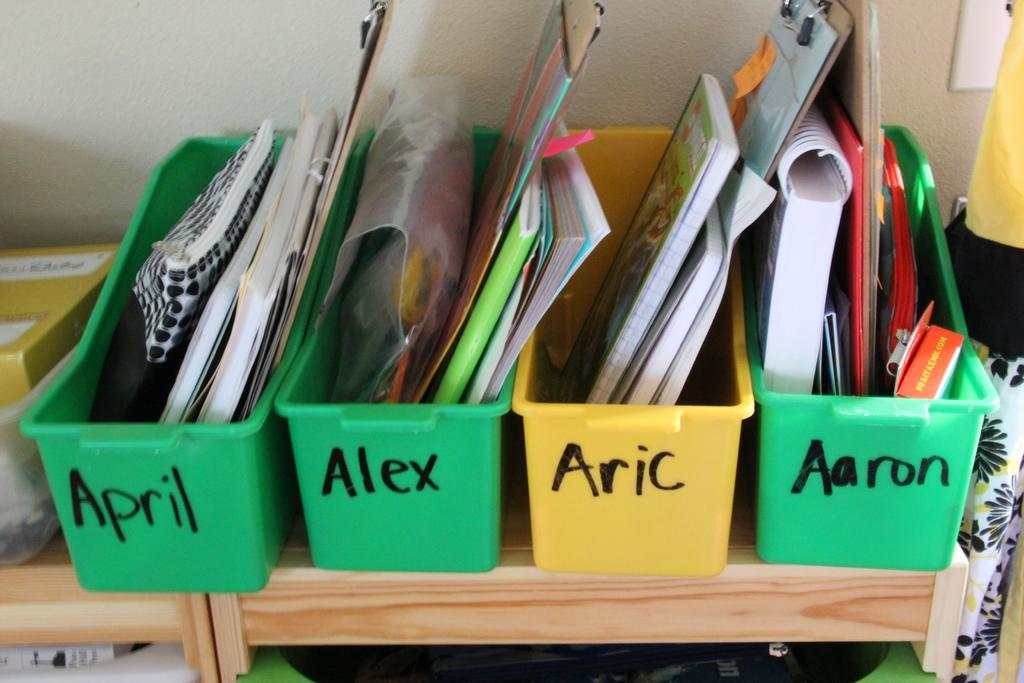<image>
Relay a brief, clear account of the picture shown. Four plastic bins are lined up on a shelf with each bin bearing a name, such as Aaron, in black marker. 